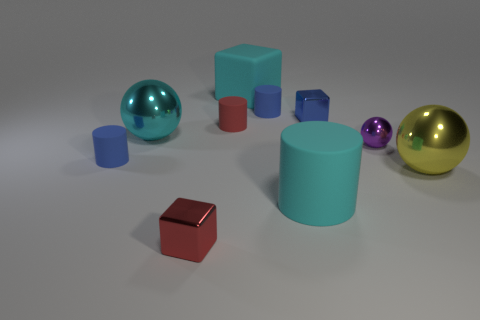Subtract all rubber cubes. How many cubes are left? 2 Subtract all purple balls. How many blue cylinders are left? 2 Subtract all red cylinders. How many cylinders are left? 3 Subtract 1 cubes. How many cubes are left? 2 Subtract all spheres. How many objects are left? 7 Add 3 tiny metallic things. How many tiny metallic things exist? 6 Subtract 1 red cubes. How many objects are left? 9 Subtract all yellow cylinders. Subtract all brown blocks. How many cylinders are left? 4 Subtract all big green blocks. Subtract all blue objects. How many objects are left? 7 Add 1 tiny purple shiny things. How many tiny purple shiny things are left? 2 